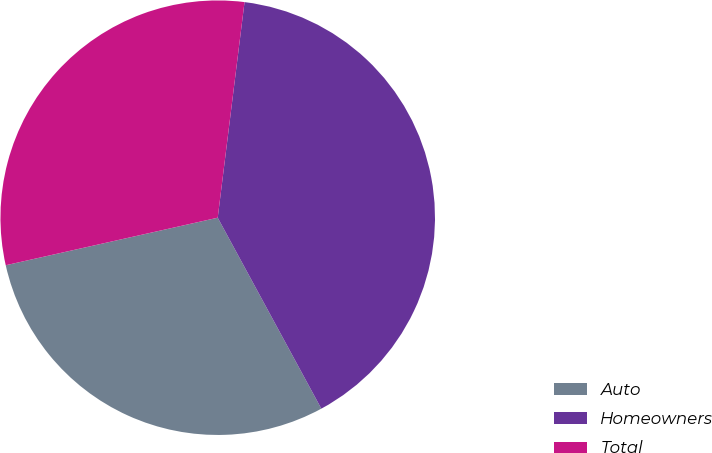Convert chart. <chart><loc_0><loc_0><loc_500><loc_500><pie_chart><fcel>Auto<fcel>Homeowners<fcel>Total<nl><fcel>29.4%<fcel>40.12%<fcel>30.48%<nl></chart> 